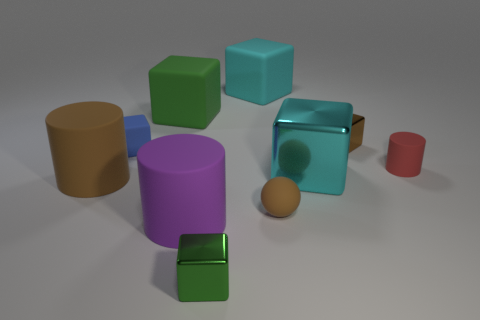Subtract all brown cylinders. How many cylinders are left? 2 Subtract 1 cubes. How many cubes are left? 5 Subtract all rubber cylinders. Subtract all green matte blocks. How many objects are left? 6 Add 6 big brown things. How many big brown things are left? 7 Add 5 small brown metal blocks. How many small brown metal blocks exist? 6 Subtract all purple cylinders. How many cylinders are left? 2 Subtract 1 brown balls. How many objects are left? 9 Subtract all balls. How many objects are left? 9 Subtract all blue spheres. Subtract all brown cylinders. How many spheres are left? 1 Subtract all brown blocks. How many brown cylinders are left? 1 